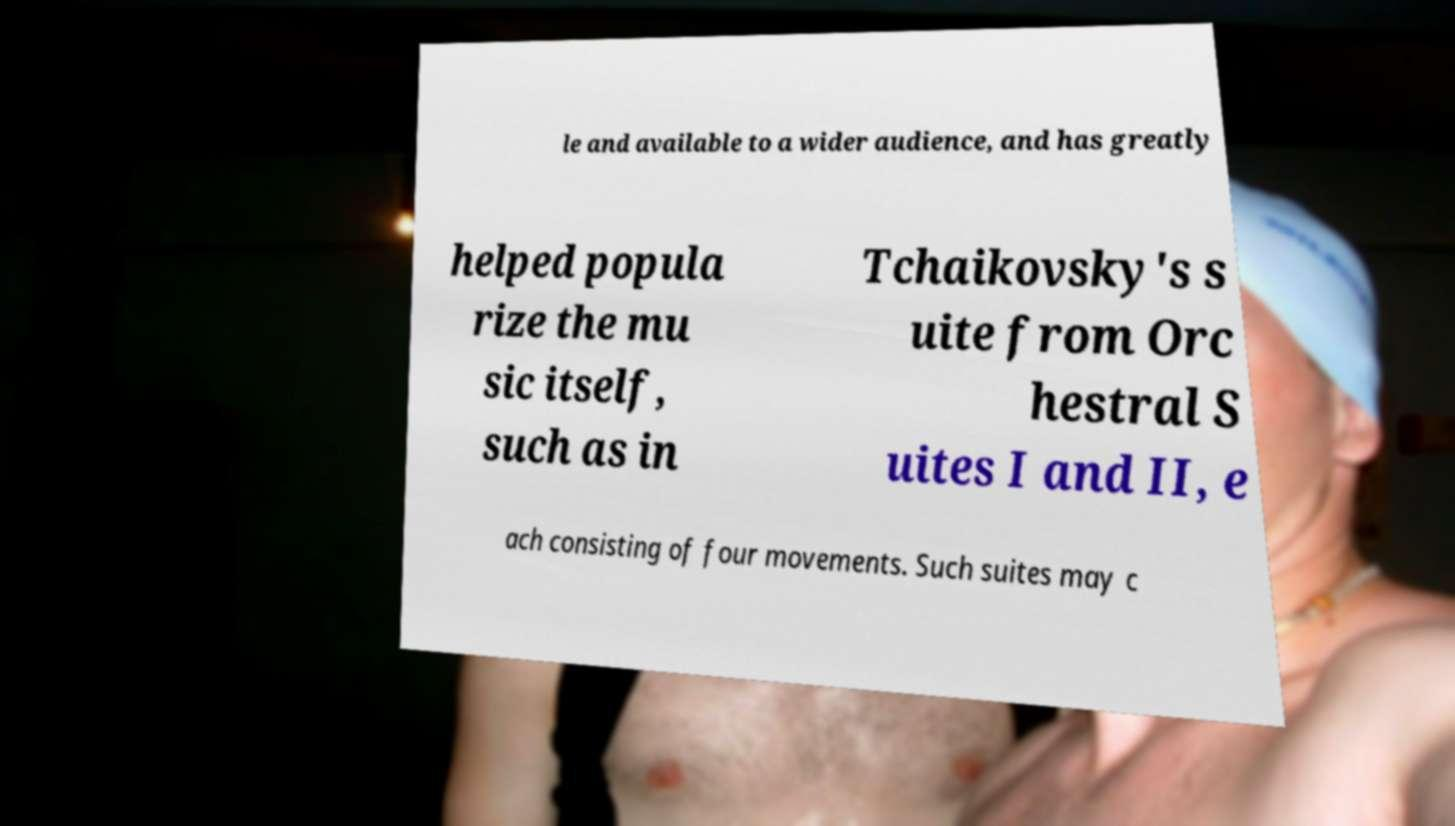Please identify and transcribe the text found in this image. le and available to a wider audience, and has greatly helped popula rize the mu sic itself, such as in Tchaikovsky's s uite from Orc hestral S uites I and II, e ach consisting of four movements. Such suites may c 